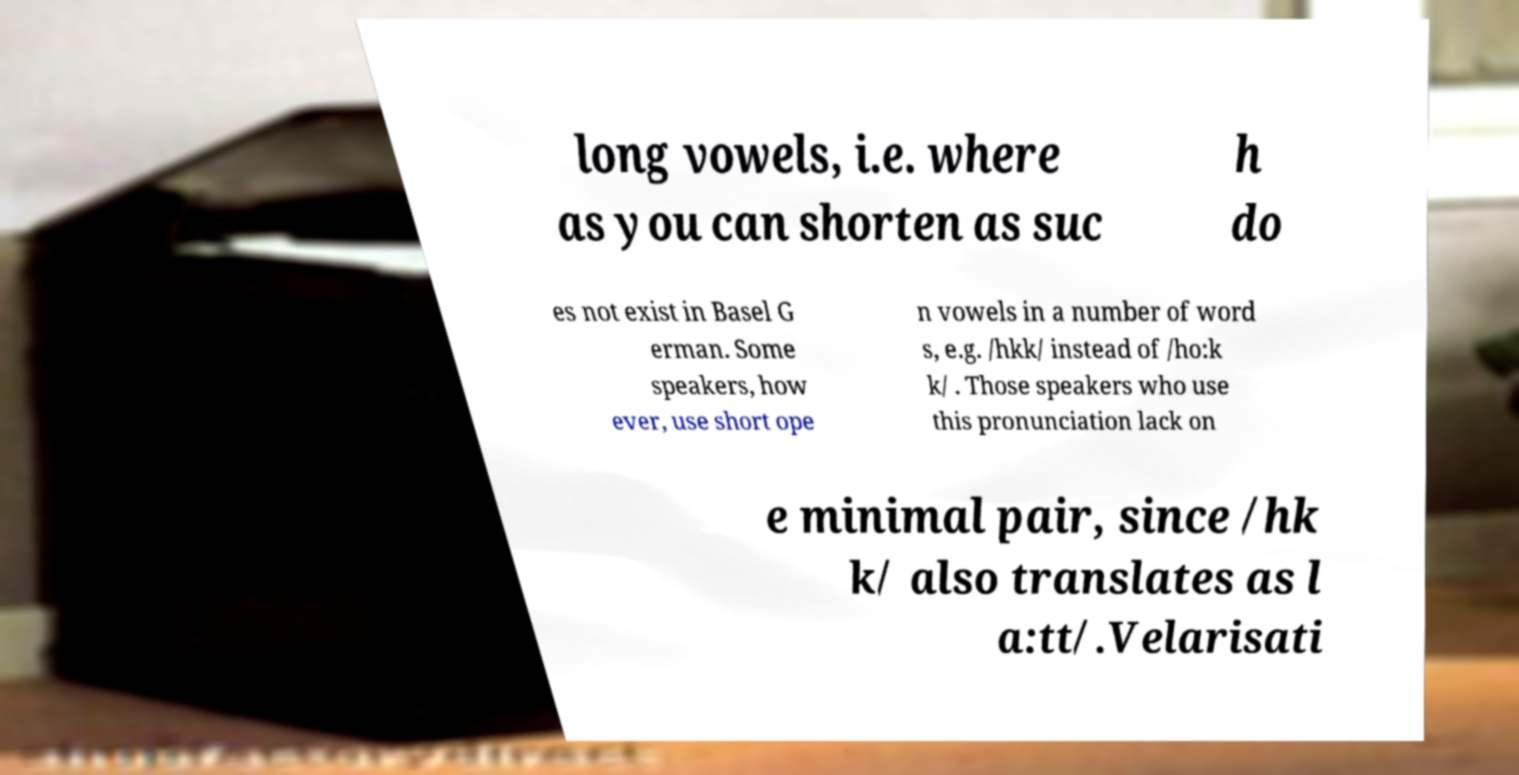There's text embedded in this image that I need extracted. Can you transcribe it verbatim? long vowels, i.e. where as you can shorten as suc h do es not exist in Basel G erman. Some speakers, how ever, use short ope n vowels in a number of word s, e.g. /hkk/ instead of /ho:k k/ . Those speakers who use this pronunciation lack on e minimal pair, since /hk k/ also translates as l a:tt/.Velarisati 